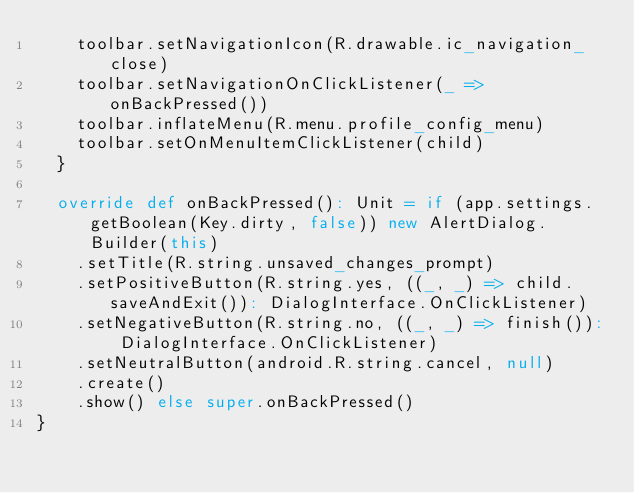Convert code to text. <code><loc_0><loc_0><loc_500><loc_500><_Scala_>    toolbar.setNavigationIcon(R.drawable.ic_navigation_close)
    toolbar.setNavigationOnClickListener(_ => onBackPressed())
    toolbar.inflateMenu(R.menu.profile_config_menu)
    toolbar.setOnMenuItemClickListener(child)
  }

  override def onBackPressed(): Unit = if (app.settings.getBoolean(Key.dirty, false)) new AlertDialog.Builder(this)
    .setTitle(R.string.unsaved_changes_prompt)
    .setPositiveButton(R.string.yes, ((_, _) => child.saveAndExit()): DialogInterface.OnClickListener)
    .setNegativeButton(R.string.no, ((_, _) => finish()): DialogInterface.OnClickListener)
    .setNeutralButton(android.R.string.cancel, null)
    .create()
    .show() else super.onBackPressed()
}
</code> 